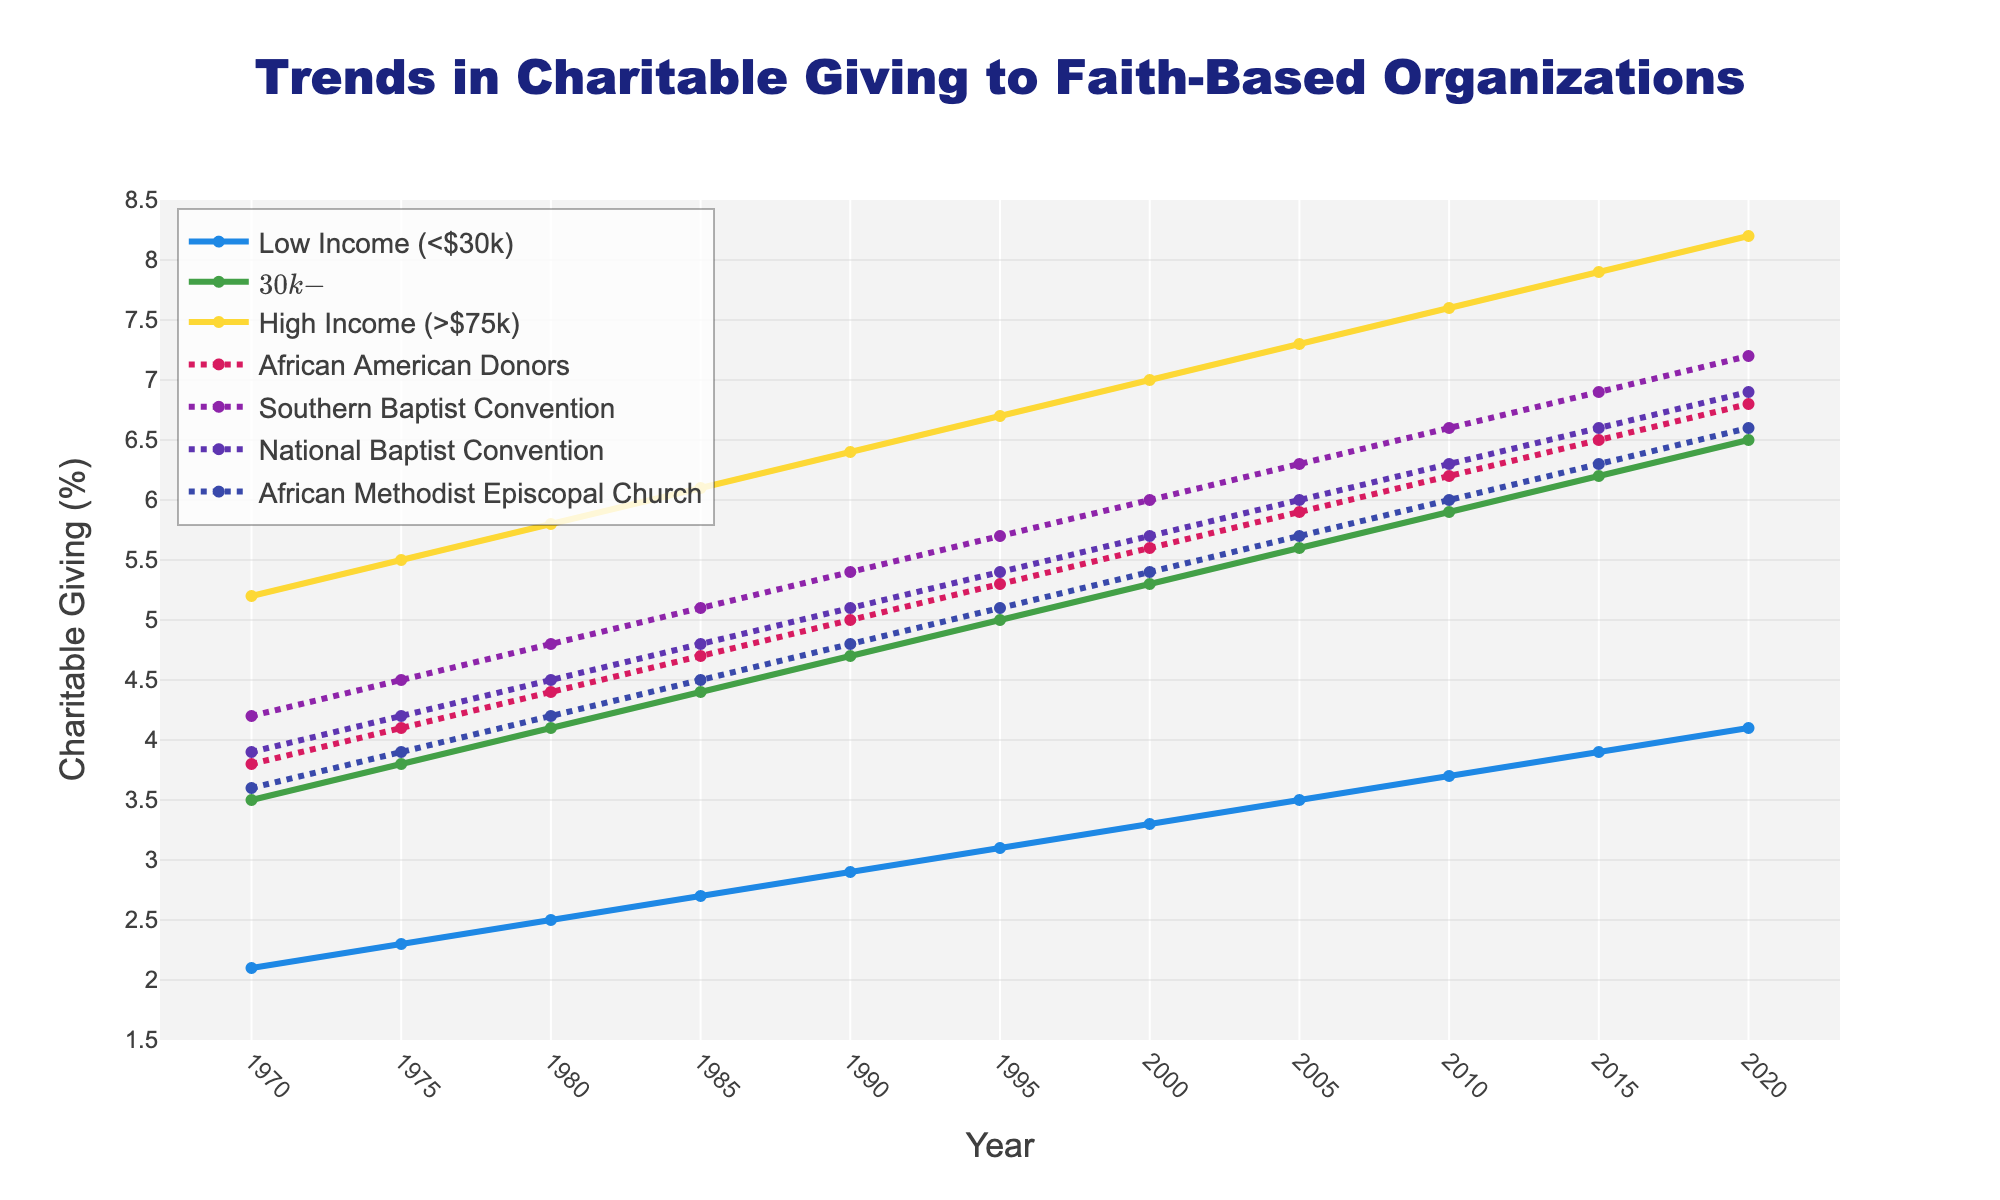What's the overall trend in charitable giving across all income brackets over the last 50 years? Starting from 1970 to 2020, the chart shows an upward trend for all income brackets. Low Income (<$30k) starts at 2.1% and rises to 4.1%, Middle Income ($30k-$75k) starts at 3.5% and rises to 6.5%, and High Income (>$75k) starts at 5.2% and rises to 8.2%.
Answer: Increasing Which income bracket had the highest charitable giving percentage in 2020? By looking at the lines in 2020, the High Income (>$75k) bracket has the highest value at 8.2%.
Answer: High Income (>$75k) How does the charitable giving trend of African American Donors compare to the Low Income bracket? Both groups show an upward trend over the years. African American Donors start at 3.8% in 1970 and rise to 6.8% in 2020. The Low Income bracket starts lower at 2.1% and ends at 4.1% in 2020. While the Low Income bracket shows a gentler rise, African American Donors increase more significantly.
Answer: African American Donors increase more significantly What is the difference between the charitable giving percentages of the Southern Baptist Convention and the National Baptist Convention in 2000? In 2000, the Southern Baptist Convention is at 6.0% and the National Baptist Convention is at 5.7%. The difference is 6.0% - 5.7% = 0.3%.
Answer: 0.3% Which group had the lowest percentage of charitable giving in the year 1980? By examining the chart for the year 1980, the "Low Income (<$30k)" line is the lowest at 2.5%.
Answer: Low Income (<$30k) What's the average charitable giving percentage of Middle Income from 1970 to 2020? Adding up the Middle Income values from 1970 to 2020 and then dividing by the number of data points (11): (3.5 + 3.8 + 4.1 + 4.4 + 4.7 + 5.0 + 5.3 + 5.6 + 5.9 + 6.2 + 6.5) / 11 = 5.0%.
Answer: 5.0% Which church shows the steepest rise in charitable giving over these 50 years? By comparing the slopes of the lines representing Southern Baptist Convention, National Baptist Convention, and African Methodist Episcopal Church, the Southern Baptist Convention shows the steepest rise, starting at 4.2% in 1970 and reaching 7.2% in 2020.
Answer: Southern Baptist Convention Has charitable giving by High Income brackets ever decreased over these 50 years? The High Income (>$75k) line consistently increases year-over-year from 5.2% in 1970 to 8.2% in 2020, showing no periods of decline.
Answer: No How did the giving trends among African American Donors and the Southern Baptist Convention compare in the year 2010? In 2010, African American Donors' percentage is 6.2%, while the Southern Baptist Convention's percentage is higher at 6.6%. Both show a rising trend, but Southern Baptist Convention has a slightly higher value.
Answer: Southern Baptist Convention is higher Estimate the average yearly increase in charitable giving for the Middle Income bracket from 1970 to 2020. Calculate the change from 1970 to 2020 for Middle Income: 6.5% - 3.5% = 3.0%. There are 50 years in the span, so the average yearly increase is 3.0% / 50 = 0.06% per year.
Answer: 0.06% per year 